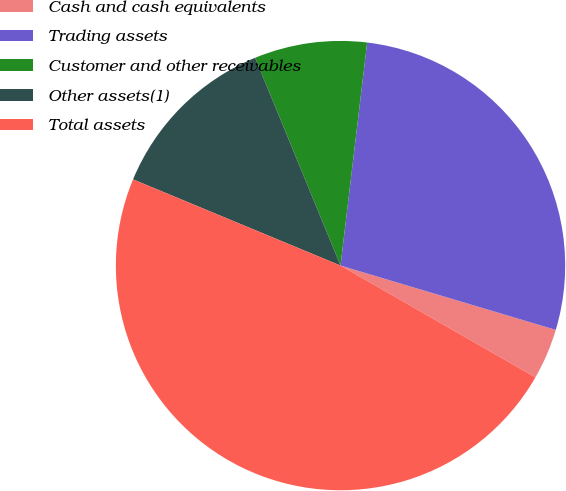Convert chart. <chart><loc_0><loc_0><loc_500><loc_500><pie_chart><fcel>Cash and cash equivalents<fcel>Trading assets<fcel>Customer and other receivables<fcel>Other assets(1)<fcel>Total assets<nl><fcel>3.67%<fcel>27.73%<fcel>8.1%<fcel>12.53%<fcel>47.98%<nl></chart> 